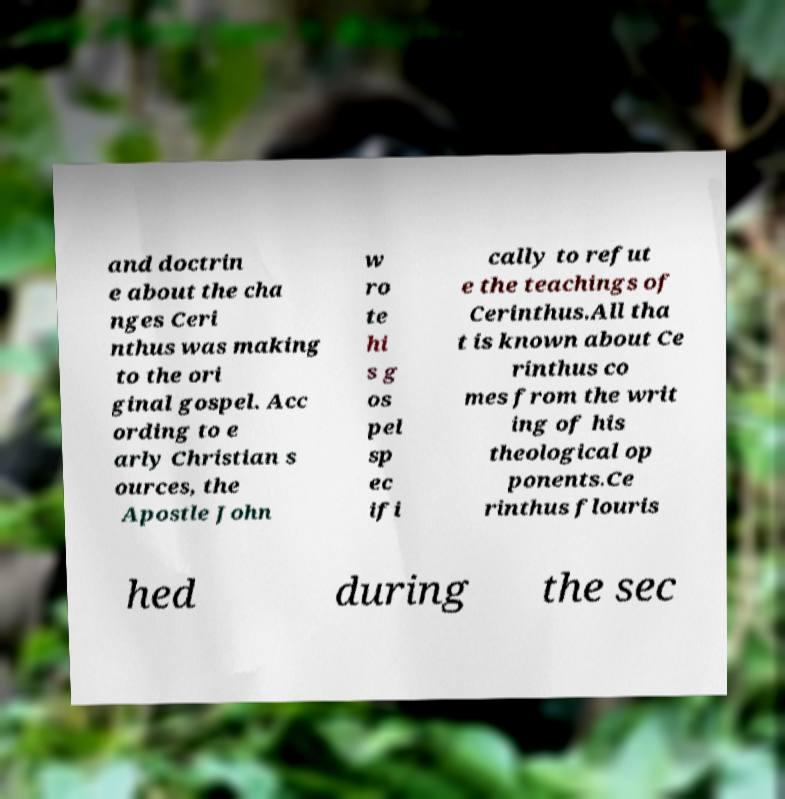Please identify and transcribe the text found in this image. and doctrin e about the cha nges Ceri nthus was making to the ori ginal gospel. Acc ording to e arly Christian s ources, the Apostle John w ro te hi s g os pel sp ec ifi cally to refut e the teachings of Cerinthus.All tha t is known about Ce rinthus co mes from the writ ing of his theological op ponents.Ce rinthus flouris hed during the sec 